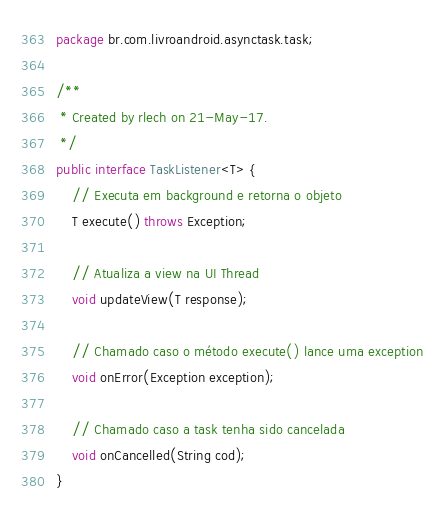Convert code to text. <code><loc_0><loc_0><loc_500><loc_500><_Java_>package br.com.livroandroid.asynctask.task;

/**
 * Created by rlech on 21-May-17.
 */
public interface TaskListener<T> {
    // Executa em background e retorna o objeto
    T execute() throws Exception;

    // Atualiza a view na UI Thread
    void updateView(T response);

    // Chamado caso o método execute() lance uma exception
    void onError(Exception exception);

    // Chamado caso a task tenha sido cancelada
    void onCancelled(String cod);
}</code> 